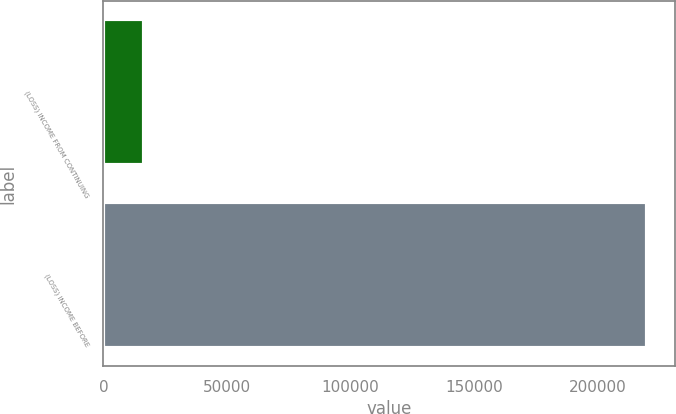Convert chart to OTSL. <chart><loc_0><loc_0><loc_500><loc_500><bar_chart><fcel>(LOSS) INCOME FROM CONTINUING<fcel>(LOSS) INCOME BEFORE<nl><fcel>16267<fcel>220185<nl></chart> 